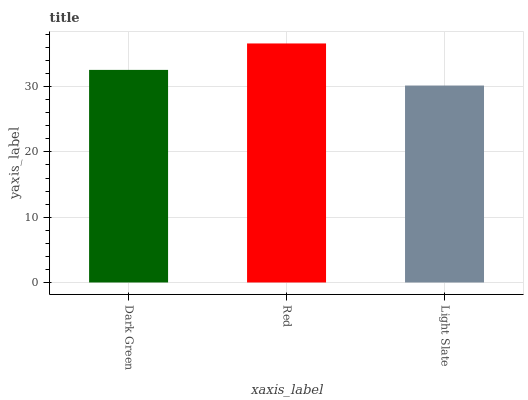Is Red the minimum?
Answer yes or no. No. Is Light Slate the maximum?
Answer yes or no. No. Is Red greater than Light Slate?
Answer yes or no. Yes. Is Light Slate less than Red?
Answer yes or no. Yes. Is Light Slate greater than Red?
Answer yes or no. No. Is Red less than Light Slate?
Answer yes or no. No. Is Dark Green the high median?
Answer yes or no. Yes. Is Dark Green the low median?
Answer yes or no. Yes. Is Light Slate the high median?
Answer yes or no. No. Is Red the low median?
Answer yes or no. No. 